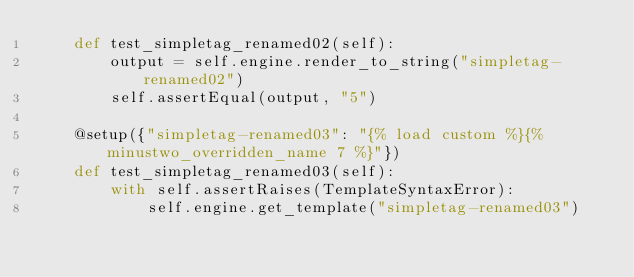<code> <loc_0><loc_0><loc_500><loc_500><_Python_>    def test_simpletag_renamed02(self):
        output = self.engine.render_to_string("simpletag-renamed02")
        self.assertEqual(output, "5")

    @setup({"simpletag-renamed03": "{% load custom %}{% minustwo_overridden_name 7 %}"})
    def test_simpletag_renamed03(self):
        with self.assertRaises(TemplateSyntaxError):
            self.engine.get_template("simpletag-renamed03")
</code> 